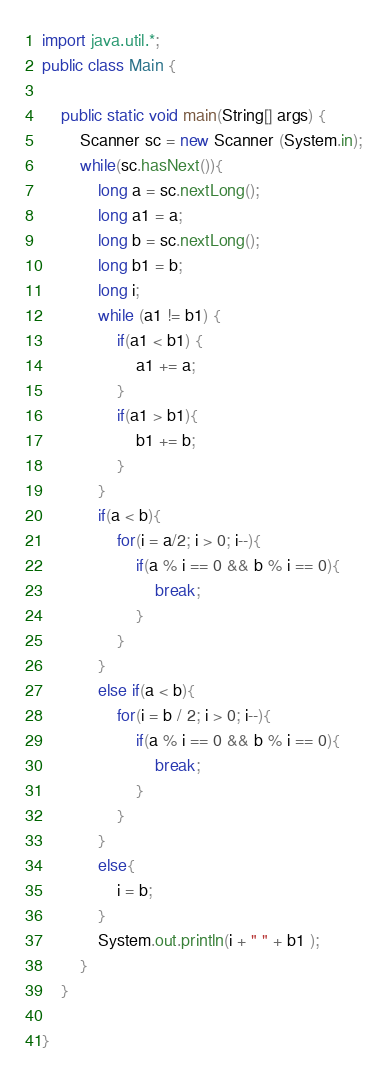<code> <loc_0><loc_0><loc_500><loc_500><_Java_>import java.util.*;
public class Main {

	public static void main(String[] args) {
		Scanner sc = new Scanner (System.in);
		while(sc.hasNext()){
			long a = sc.nextLong();
			long a1 = a;
			long b = sc.nextLong();
			long b1 = b;
			long i;
			while (a1 != b1) {
				if(a1 < b1) {
					a1 += a;
				}
				if(a1 > b1){
					b1 += b;
				}
			}
			if(a < b){
				for(i = a/2; i > 0; i--){
					if(a % i == 0 && b % i == 0){
						break;
					}
				}
			}
			else if(a < b){
				for(i = b / 2; i > 0; i--){
					if(a % i == 0 && b % i == 0){
						break;
					}
				}
			}
			else{
				i = b;
			}
			System.out.println(i + " " + b1 );
		}
	}

}</code> 